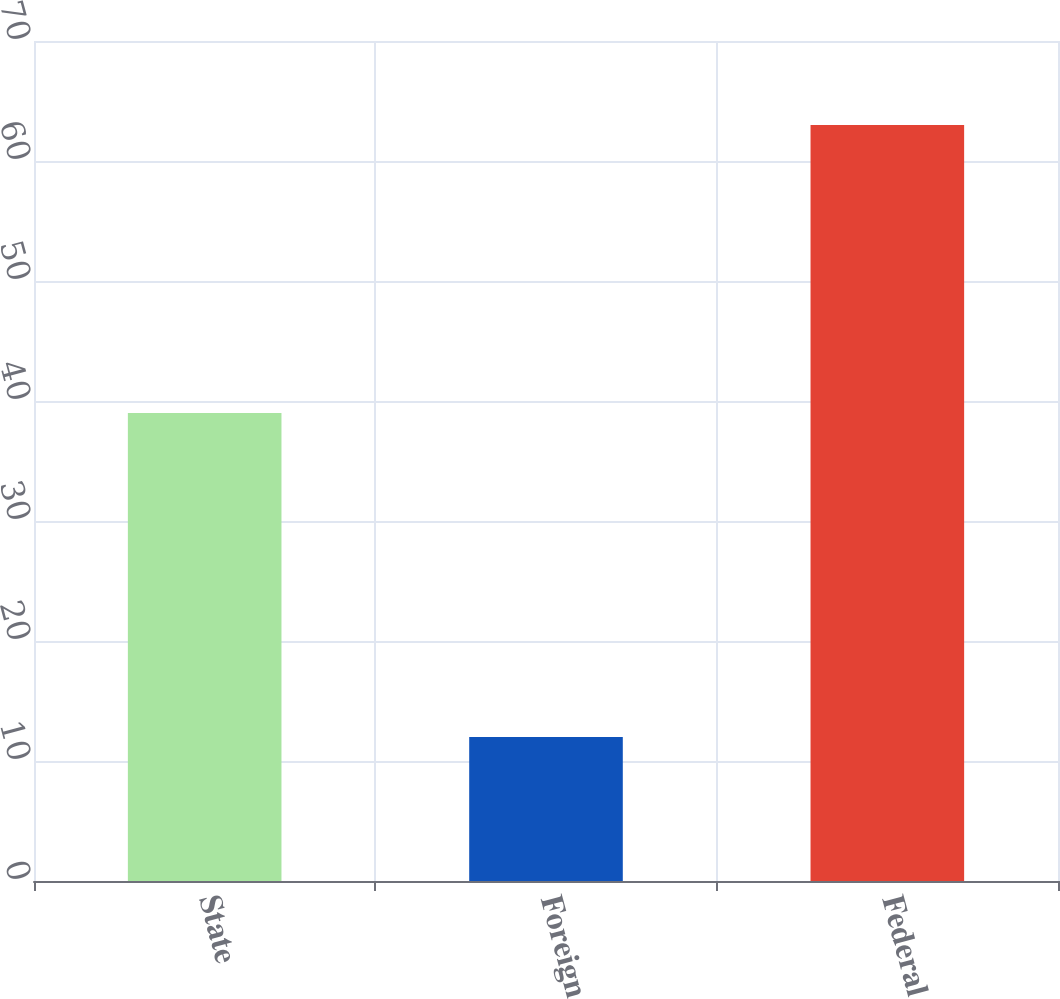<chart> <loc_0><loc_0><loc_500><loc_500><bar_chart><fcel>State<fcel>Foreign<fcel>Federal<nl><fcel>39<fcel>12<fcel>63<nl></chart> 